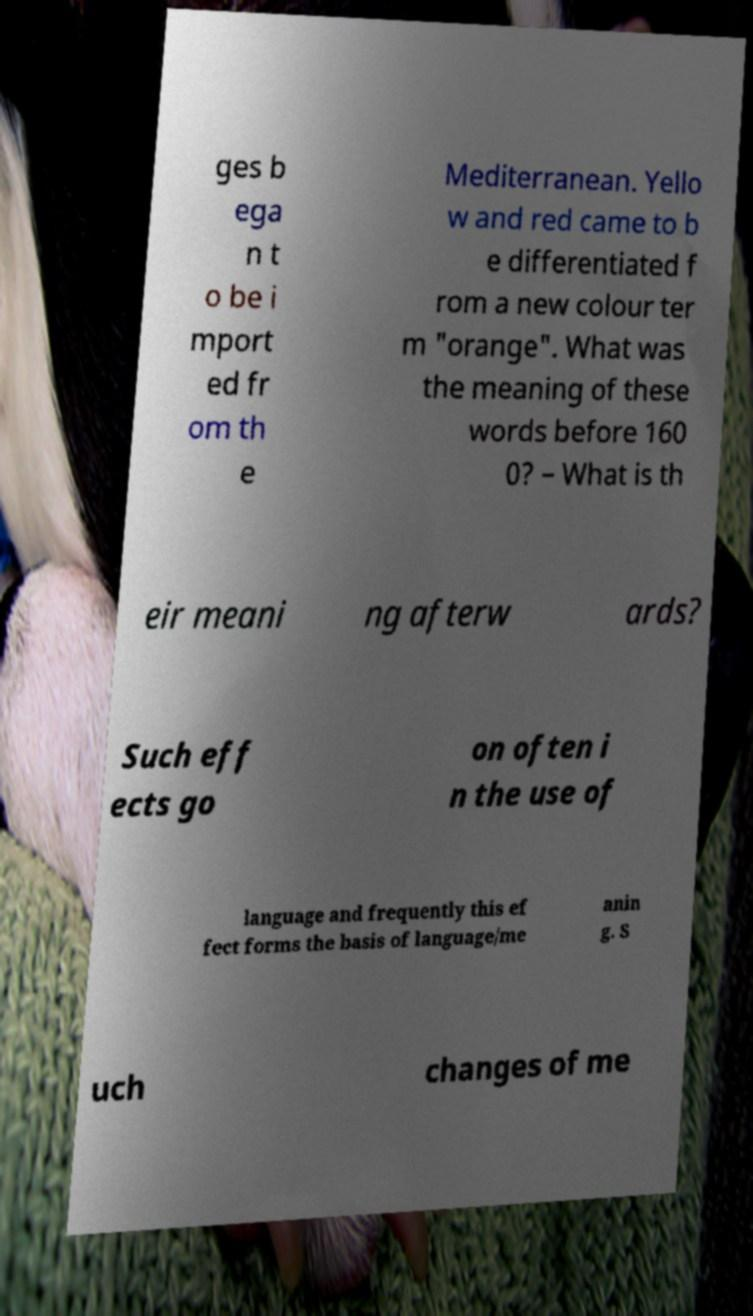There's text embedded in this image that I need extracted. Can you transcribe it verbatim? ges b ega n t o be i mport ed fr om th e Mediterranean. Yello w and red came to b e differentiated f rom a new colour ter m "orange". What was the meaning of these words before 160 0? – What is th eir meani ng afterw ards? Such eff ects go on often i n the use of language and frequently this ef fect forms the basis of language/me anin g. S uch changes of me 